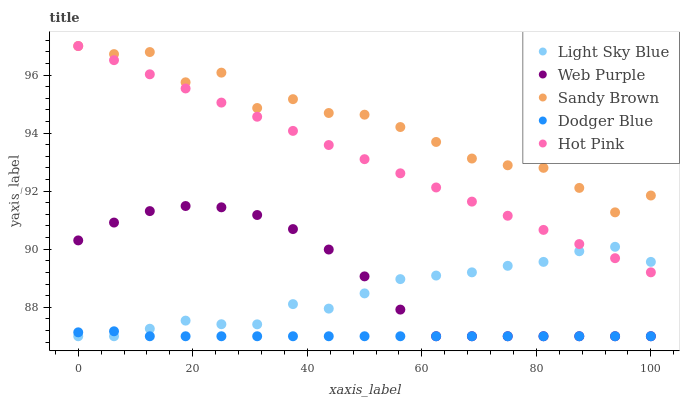Does Dodger Blue have the minimum area under the curve?
Answer yes or no. Yes. Does Sandy Brown have the maximum area under the curve?
Answer yes or no. Yes. Does Web Purple have the minimum area under the curve?
Answer yes or no. No. Does Web Purple have the maximum area under the curve?
Answer yes or no. No. Is Hot Pink the smoothest?
Answer yes or no. Yes. Is Sandy Brown the roughest?
Answer yes or no. Yes. Is Web Purple the smoothest?
Answer yes or no. No. Is Web Purple the roughest?
Answer yes or no. No. Does Dodger Blue have the lowest value?
Answer yes or no. Yes. Does Sandy Brown have the lowest value?
Answer yes or no. No. Does Hot Pink have the highest value?
Answer yes or no. Yes. Does Web Purple have the highest value?
Answer yes or no. No. Is Dodger Blue less than Hot Pink?
Answer yes or no. Yes. Is Sandy Brown greater than Web Purple?
Answer yes or no. Yes. Does Light Sky Blue intersect Dodger Blue?
Answer yes or no. Yes. Is Light Sky Blue less than Dodger Blue?
Answer yes or no. No. Is Light Sky Blue greater than Dodger Blue?
Answer yes or no. No. Does Dodger Blue intersect Hot Pink?
Answer yes or no. No. 